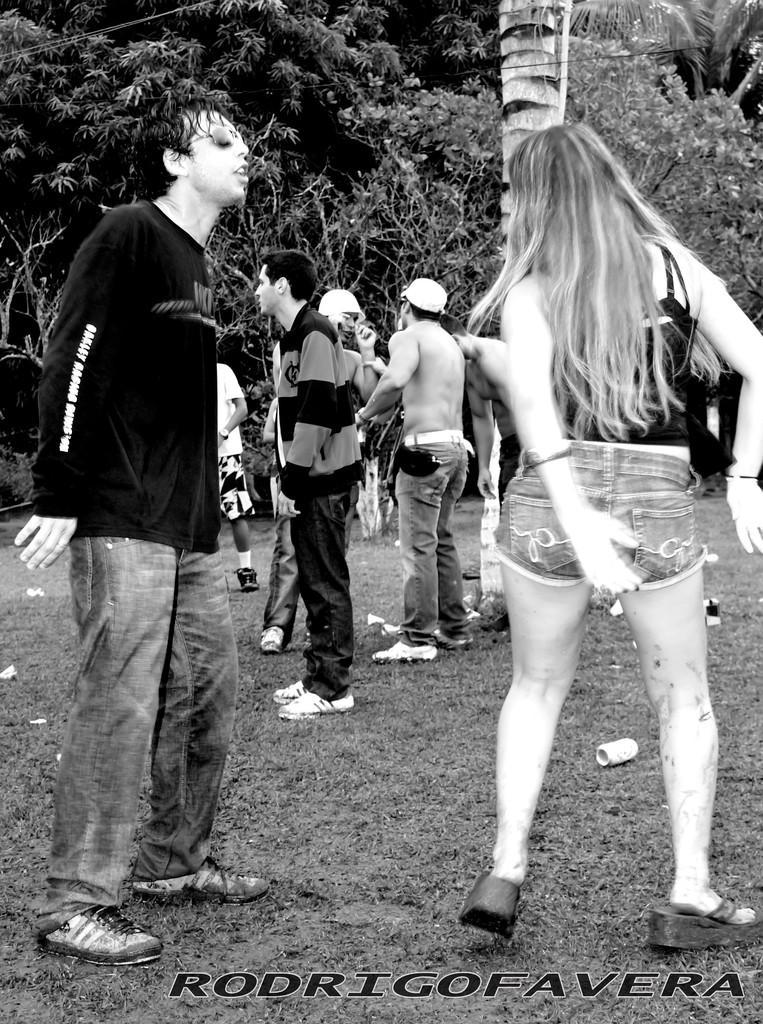Could you give a brief overview of what you see in this image? In this image we can see a few people, there is a soda can on the ground, there are trees, also we can see the text on the image, and the picture is taken in black and white mode. 